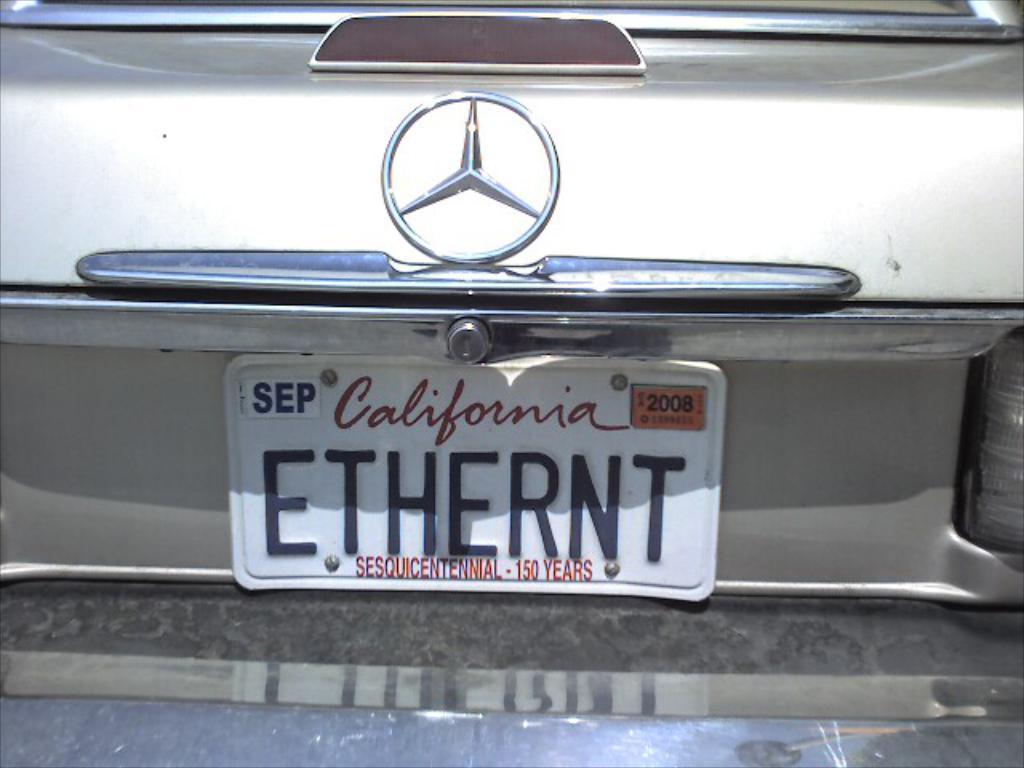Which state registered the car?
Provide a short and direct response. California. 